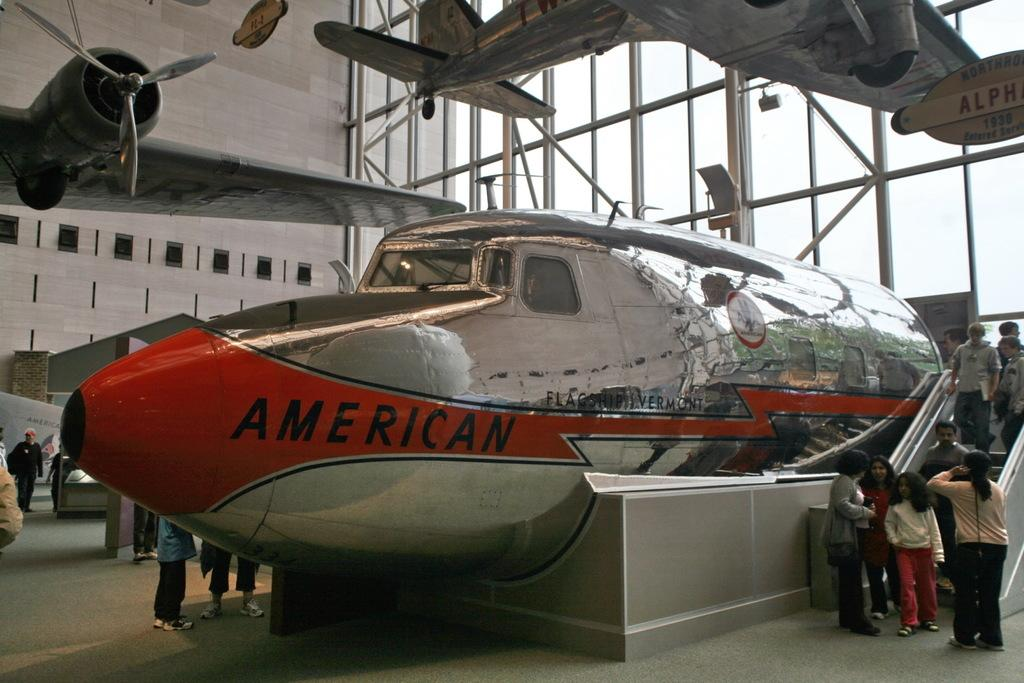<image>
Summarize the visual content of the image. An old silver plane with the word "American" written on the front. 